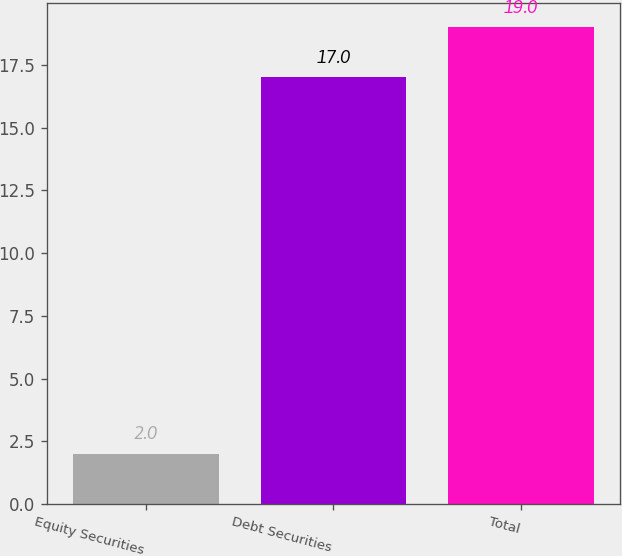Convert chart to OTSL. <chart><loc_0><loc_0><loc_500><loc_500><bar_chart><fcel>Equity Securities<fcel>Debt Securities<fcel>Total<nl><fcel>2<fcel>17<fcel>19<nl></chart> 